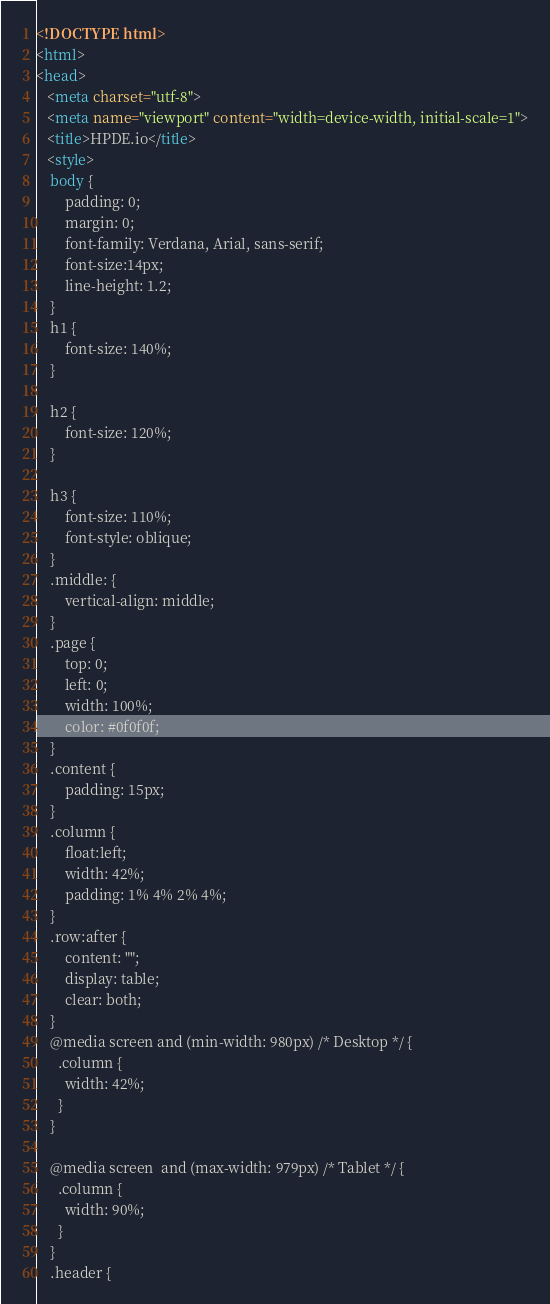<code> <loc_0><loc_0><loc_500><loc_500><_HTML_><!DOCTYPE html>
<html>
<head>
   <meta charset="utf-8">
   <meta name="viewport" content="width=device-width, initial-scale=1">
   <title>HPDE.io</title>
   <style>
	body {
		padding: 0;
		margin: 0;
		font-family: Verdana, Arial, sans-serif; 
		font-size:14px; 
		line-height: 1.2;
	}
	h1 {
		font-size: 140%;
	}

	h2 {
		font-size: 120%;
	}

	h3 {
		font-size: 110%;
		font-style: oblique;
	}
	.middle: {
		vertical-align: middle;
	}
	.page {
		top: 0;
		left: 0;
		width: 100%;
		color: #0f0f0f;
	}
	.content {
		padding: 15px;
	}
	.column {
		float:left;
		width: 42%;
		padding: 1% 4% 2% 4%;
	}
	.row:after {
		content: "";
		display: table;
		clear: both;
	}	
	@media screen and (min-width: 980px) /* Desktop */ {
	  .column {
		width: 42%;
	  }
	}

	@media screen  and (max-width: 979px) /* Tablet */ {
	  .column {
		width: 90%;
	  }
	}
	.header {</code> 